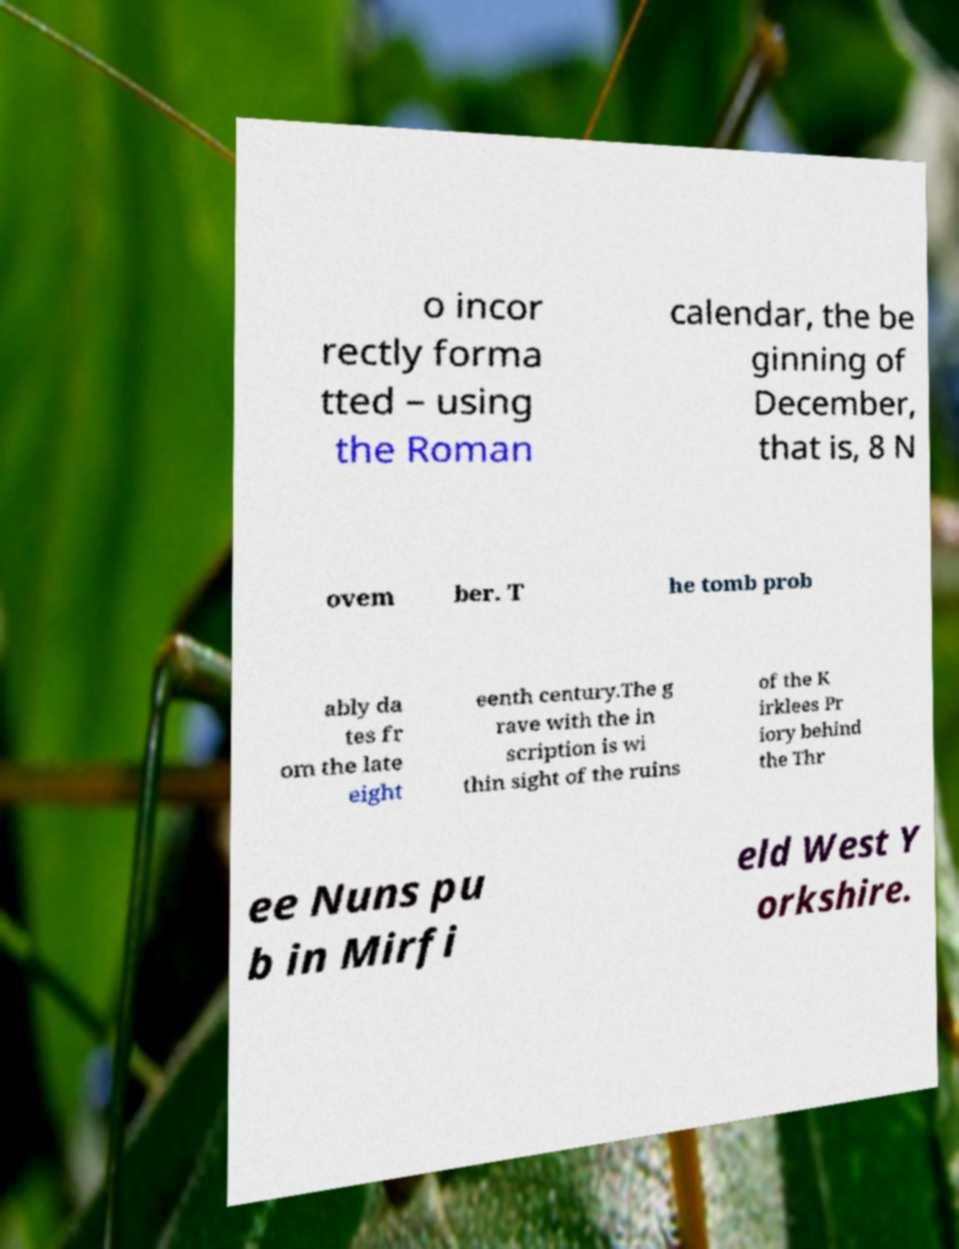Could you extract and type out the text from this image? o incor rectly forma tted – using the Roman calendar, the be ginning of December, that is, 8 N ovem ber. T he tomb prob ably da tes fr om the late eight eenth century.The g rave with the in scription is wi thin sight of the ruins of the K irklees Pr iory behind the Thr ee Nuns pu b in Mirfi eld West Y orkshire. 